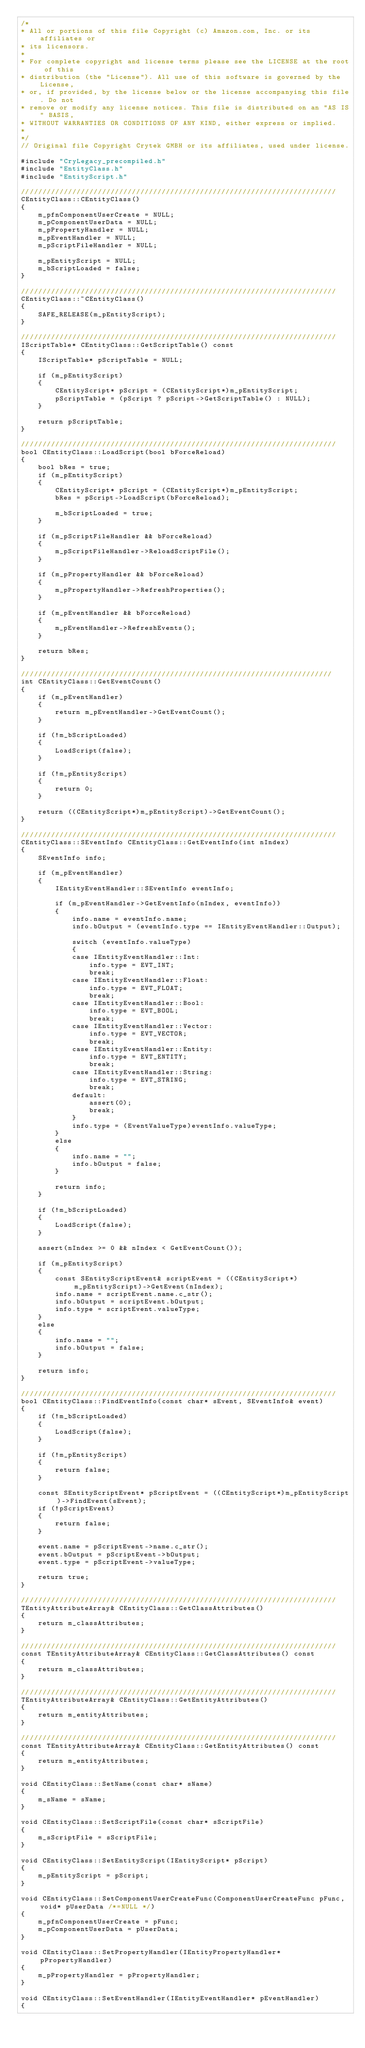<code> <loc_0><loc_0><loc_500><loc_500><_C++_>/*
* All or portions of this file Copyright (c) Amazon.com, Inc. or its affiliates or
* its licensors.
*
* For complete copyright and license terms please see the LICENSE at the root of this
* distribution (the "License"). All use of this software is governed by the License,
* or, if provided, by the license below or the license accompanying this file. Do not
* remove or modify any license notices. This file is distributed on an "AS IS" BASIS,
* WITHOUT WARRANTIES OR CONDITIONS OF ANY KIND, either express or implied.
*
*/
// Original file Copyright Crytek GMBH or its affiliates, used under license.

#include "CryLegacy_precompiled.h"
#include "EntityClass.h"
#include "EntityScript.h"

//////////////////////////////////////////////////////////////////////////
CEntityClass::CEntityClass()
{
    m_pfnComponentUserCreate = NULL;
    m_pComponentUserData = NULL;
    m_pPropertyHandler = NULL;
    m_pEventHandler = NULL;
    m_pScriptFileHandler = NULL;

    m_pEntityScript = NULL;
    m_bScriptLoaded = false;
}

//////////////////////////////////////////////////////////////////////////
CEntityClass::~CEntityClass()
{
    SAFE_RELEASE(m_pEntityScript);
}

//////////////////////////////////////////////////////////////////////////
IScriptTable* CEntityClass::GetScriptTable() const
{
    IScriptTable* pScriptTable = NULL;

    if (m_pEntityScript)
    {
        CEntityScript* pScript = (CEntityScript*)m_pEntityScript;
        pScriptTable = (pScript ? pScript->GetScriptTable() : NULL);
    }

    return pScriptTable;
}

//////////////////////////////////////////////////////////////////////////
bool CEntityClass::LoadScript(bool bForceReload)
{
    bool bRes = true;
    if (m_pEntityScript)
    {
        CEntityScript* pScript = (CEntityScript*)m_pEntityScript;
        bRes = pScript->LoadScript(bForceReload);

        m_bScriptLoaded = true;
    }

    if (m_pScriptFileHandler && bForceReload)
    {
        m_pScriptFileHandler->ReloadScriptFile();
    }

    if (m_pPropertyHandler && bForceReload)
    {
        m_pPropertyHandler->RefreshProperties();
    }

    if (m_pEventHandler && bForceReload)
    {
        m_pEventHandler->RefreshEvents();
    }

    return bRes;
}

/////////////////////////////////////////////////////////////////////////
int CEntityClass::GetEventCount()
{
    if (m_pEventHandler)
    {
        return m_pEventHandler->GetEventCount();
    }

    if (!m_bScriptLoaded)
    {
        LoadScript(false);
    }

    if (!m_pEntityScript)
    {
        return 0;
    }

    return ((CEntityScript*)m_pEntityScript)->GetEventCount();
}

//////////////////////////////////////////////////////////////////////////
CEntityClass::SEventInfo CEntityClass::GetEventInfo(int nIndex)
{
    SEventInfo info;

    if (m_pEventHandler)
    {
        IEntityEventHandler::SEventInfo eventInfo;

        if (m_pEventHandler->GetEventInfo(nIndex, eventInfo))
        {
            info.name = eventInfo.name;
            info.bOutput = (eventInfo.type == IEntityEventHandler::Output);

            switch (eventInfo.valueType)
            {
            case IEntityEventHandler::Int:
                info.type = EVT_INT;
                break;
            case IEntityEventHandler::Float:
                info.type = EVT_FLOAT;
                break;
            case IEntityEventHandler::Bool:
                info.type = EVT_BOOL;
                break;
            case IEntityEventHandler::Vector:
                info.type = EVT_VECTOR;
                break;
            case IEntityEventHandler::Entity:
                info.type = EVT_ENTITY;
                break;
            case IEntityEventHandler::String:
                info.type = EVT_STRING;
                break;
            default:
                assert(0);
                break;
            }
            info.type = (EventValueType)eventInfo.valueType;
        }
        else
        {
            info.name = "";
            info.bOutput = false;
        }

        return info;
    }

    if (!m_bScriptLoaded)
    {
        LoadScript(false);
    }

    assert(nIndex >= 0 && nIndex < GetEventCount());

    if (m_pEntityScript)
    {
        const SEntityScriptEvent& scriptEvent = ((CEntityScript*)m_pEntityScript)->GetEvent(nIndex);
        info.name = scriptEvent.name.c_str();
        info.bOutput = scriptEvent.bOutput;
        info.type = scriptEvent.valueType;
    }
    else
    {
        info.name = "";
        info.bOutput = false;
    }

    return info;
}

//////////////////////////////////////////////////////////////////////////
bool CEntityClass::FindEventInfo(const char* sEvent, SEventInfo& event)
{
    if (!m_bScriptLoaded)
    {
        LoadScript(false);
    }

    if (!m_pEntityScript)
    {
        return false;
    }

    const SEntityScriptEvent* pScriptEvent = ((CEntityScript*)m_pEntityScript)->FindEvent(sEvent);
    if (!pScriptEvent)
    {
        return false;
    }

    event.name = pScriptEvent->name.c_str();
    event.bOutput = pScriptEvent->bOutput;
    event.type = pScriptEvent->valueType;

    return true;
}

//////////////////////////////////////////////////////////////////////////
TEntityAttributeArray& CEntityClass::GetClassAttributes()
{
    return m_classAttributes;
}

//////////////////////////////////////////////////////////////////////////
const TEntityAttributeArray& CEntityClass::GetClassAttributes() const
{
    return m_classAttributes;
}

//////////////////////////////////////////////////////////////////////////
TEntityAttributeArray& CEntityClass::GetEntityAttributes()
{
    return m_entityAttributes;
}

//////////////////////////////////////////////////////////////////////////
const TEntityAttributeArray& CEntityClass::GetEntityAttributes() const
{
    return m_entityAttributes;
}

void CEntityClass::SetName(const char* sName)
{
    m_sName = sName;
}

void CEntityClass::SetScriptFile(const char* sScriptFile)
{
    m_sScriptFile = sScriptFile;
}

void CEntityClass::SetEntityScript(IEntityScript* pScript)
{
    m_pEntityScript = pScript;
}

void CEntityClass::SetComponentUserCreateFunc(ComponentUserCreateFunc pFunc, void* pUserData /*=NULL */)
{
    m_pfnComponentUserCreate = pFunc;
    m_pComponentUserData = pUserData;
}

void CEntityClass::SetPropertyHandler(IEntityPropertyHandler* pPropertyHandler)
{
    m_pPropertyHandler = pPropertyHandler;
}

void CEntityClass::SetEventHandler(IEntityEventHandler* pEventHandler)
{</code> 